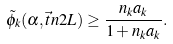Convert formula to latex. <formula><loc_0><loc_0><loc_500><loc_500>\tilde { \phi } _ { k } ( \alpha , \vec { t } { n } { 2 } { L } ) \geq \frac { n _ { k } a _ { k } } { 1 + n _ { k } a _ { k } } .</formula> 